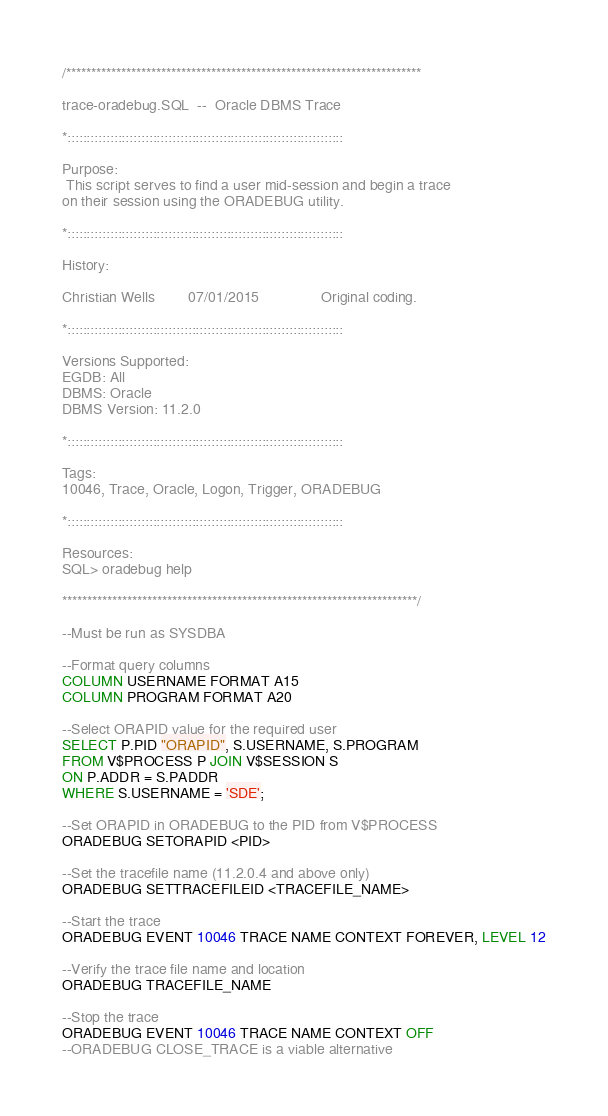<code> <loc_0><loc_0><loc_500><loc_500><_SQL_>/***********************************************************************

trace-oradebug.SQL  --  Oracle DBMS Trace

*:::::::::::::::::::::::::::::::::::::::::::::::::::::::::::::::::::::::

Purpose:
 This script serves to find a user mid-session and begin a trace
on their session using the ORADEBUG utility.

*:::::::::::::::::::::::::::::::::::::::::::::::::::::::::::::::::::::::

History:

Christian Wells        07/01/2015               Original coding.

*:::::::::::::::::::::::::::::::::::::::::::::::::::::::::::::::::::::::

Versions Supported:
EGDB: All
DBMS: Oracle
DBMS Version: 11.2.0

*:::::::::::::::::::::::::::::::::::::::::::::::::::::::::::::::::::::::

Tags:
10046, Trace, Oracle, Logon, Trigger, ORADEBUG

*:::::::::::::::::::::::::::::::::::::::::::::::::::::::::::::::::::::::

Resources:
SQL> oradebug help

***********************************************************************/

--Must be run as SYSDBA

--Format query columns
COLUMN USERNAME FORMAT A15
COLUMN PROGRAM FORMAT A20

--Select ORAPID value for the required user
SELECT P.PID "ORAPID", S.USERNAME, S.PROGRAM
FROM V$PROCESS P JOIN V$SESSION S
ON P.ADDR = S.PADDR
WHERE S.USERNAME = 'SDE';

--Set ORAPID in ORADEBUG to the PID from V$PROCESS
ORADEBUG SETORAPID <PID>

--Set the tracefile name (11.2.0.4 and above only)
ORADEBUG SETTRACEFILEID <TRACEFILE_NAME>

--Start the trace
ORADEBUG EVENT 10046 TRACE NAME CONTEXT FOREVER, LEVEL 12

--Verify the trace file name and location
ORADEBUG TRACEFILE_NAME

--Stop the trace
ORADEBUG EVENT 10046 TRACE NAME CONTEXT OFF
--ORADEBUG CLOSE_TRACE is a viable alternative
</code> 